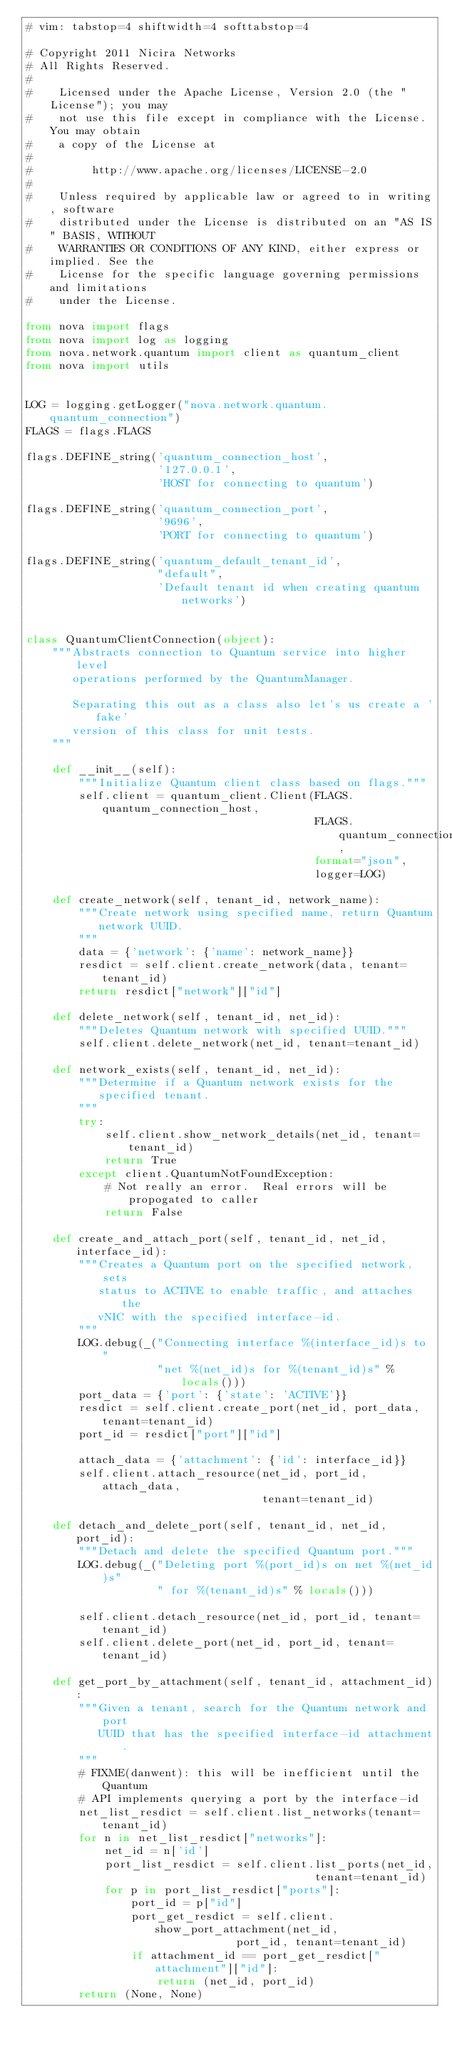<code> <loc_0><loc_0><loc_500><loc_500><_Python_># vim: tabstop=4 shiftwidth=4 softtabstop=4

# Copyright 2011 Nicira Networks
# All Rights Reserved.
#
#    Licensed under the Apache License, Version 2.0 (the "License"); you may
#    not use this file except in compliance with the License. You may obtain
#    a copy of the License at
#
#         http://www.apache.org/licenses/LICENSE-2.0
#
#    Unless required by applicable law or agreed to in writing, software
#    distributed under the License is distributed on an "AS IS" BASIS, WITHOUT
#    WARRANTIES OR CONDITIONS OF ANY KIND, either express or implied. See the
#    License for the specific language governing permissions and limitations
#    under the License.

from nova import flags
from nova import log as logging
from nova.network.quantum import client as quantum_client
from nova import utils


LOG = logging.getLogger("nova.network.quantum.quantum_connection")
FLAGS = flags.FLAGS

flags.DEFINE_string('quantum_connection_host',
                    '127.0.0.1',
                    'HOST for connecting to quantum')

flags.DEFINE_string('quantum_connection_port',
                    '9696',
                    'PORT for connecting to quantum')

flags.DEFINE_string('quantum_default_tenant_id',
                    "default",
                    'Default tenant id when creating quantum networks')


class QuantumClientConnection(object):
    """Abstracts connection to Quantum service into higher level
       operations performed by the QuantumManager.

       Separating this out as a class also let's us create a 'fake'
       version of this class for unit tests.
    """

    def __init__(self):
        """Initialize Quantum client class based on flags."""
        self.client = quantum_client.Client(FLAGS.quantum_connection_host,
                                            FLAGS.quantum_connection_port,
                                            format="json",
                                            logger=LOG)

    def create_network(self, tenant_id, network_name):
        """Create network using specified name, return Quantum
           network UUID.
        """
        data = {'network': {'name': network_name}}
        resdict = self.client.create_network(data, tenant=tenant_id)
        return resdict["network"]["id"]

    def delete_network(self, tenant_id, net_id):
        """Deletes Quantum network with specified UUID."""
        self.client.delete_network(net_id, tenant=tenant_id)

    def network_exists(self, tenant_id, net_id):
        """Determine if a Quantum network exists for the
           specified tenant.
        """
        try:
            self.client.show_network_details(net_id, tenant=tenant_id)
            return True
        except client.QuantumNotFoundException:
            # Not really an error.  Real errors will be propogated to caller
            return False

    def create_and_attach_port(self, tenant_id, net_id, interface_id):
        """Creates a Quantum port on the specified network, sets
           status to ACTIVE to enable traffic, and attaches the
           vNIC with the specified interface-id.
        """
        LOG.debug(_("Connecting interface %(interface_id)s to "
                    "net %(net_id)s for %(tenant_id)s" % locals()))
        port_data = {'port': {'state': 'ACTIVE'}}
        resdict = self.client.create_port(net_id, port_data, tenant=tenant_id)
        port_id = resdict["port"]["id"]

        attach_data = {'attachment': {'id': interface_id}}
        self.client.attach_resource(net_id, port_id, attach_data,
                                    tenant=tenant_id)

    def detach_and_delete_port(self, tenant_id, net_id, port_id):
        """Detach and delete the specified Quantum port."""
        LOG.debug(_("Deleting port %(port_id)s on net %(net_id)s"
                    " for %(tenant_id)s" % locals()))

        self.client.detach_resource(net_id, port_id, tenant=tenant_id)
        self.client.delete_port(net_id, port_id, tenant=tenant_id)

    def get_port_by_attachment(self, tenant_id, attachment_id):
        """Given a tenant, search for the Quantum network and port
           UUID that has the specified interface-id attachment.
        """
        # FIXME(danwent): this will be inefficient until the Quantum
        # API implements querying a port by the interface-id
        net_list_resdict = self.client.list_networks(tenant=tenant_id)
        for n in net_list_resdict["networks"]:
            net_id = n['id']
            port_list_resdict = self.client.list_ports(net_id,
                                            tenant=tenant_id)
            for p in port_list_resdict["ports"]:
                port_id = p["id"]
                port_get_resdict = self.client.show_port_attachment(net_id,
                                port_id, tenant=tenant_id)
                if attachment_id == port_get_resdict["attachment"]["id"]:
                    return (net_id, port_id)
        return (None, None)
</code> 